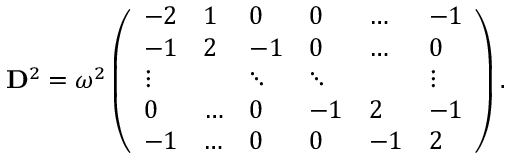Convert formula to latex. <formula><loc_0><loc_0><loc_500><loc_500>D ^ { 2 } = \omega ^ { 2 } \left ( \begin{array} { l l l l l l } { - 2 } & { 1 } & { 0 } & { 0 } & { \dots } & { - 1 } \\ { - 1 } & { 2 } & { - 1 } & { 0 } & { \dots } & { 0 } \\ { \vdots } & & { \ddots } & { \ddots } & & { \vdots } \\ { 0 } & { \dots } & { 0 } & { - 1 } & { 2 } & { - 1 } \\ { - 1 } & { \dots } & { 0 } & { 0 } & { - 1 } & { 2 } \end{array} \right ) .</formula> 